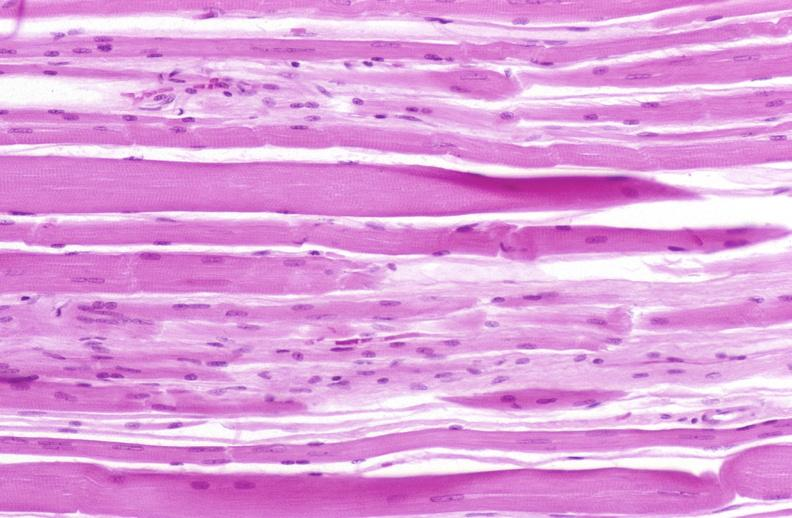does this image show skeletal muscle atrophy?
Answer the question using a single word or phrase. Yes 